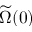Convert formula to latex. <formula><loc_0><loc_0><loc_500><loc_500>\widetilde { \Omega } ( 0 )</formula> 